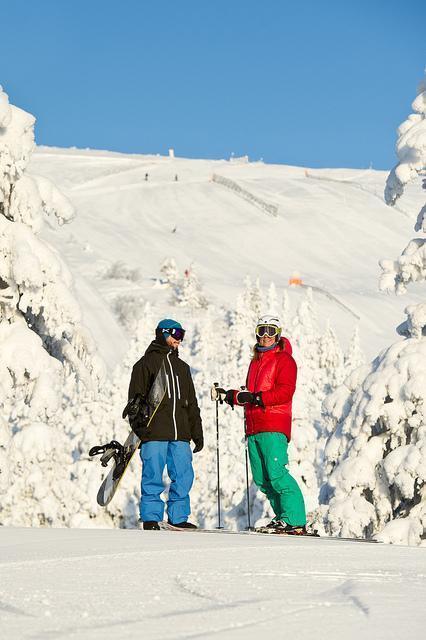How many people can be seen?
Give a very brief answer. 2. How many bicycles are on the road?
Give a very brief answer. 0. 